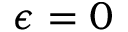<formula> <loc_0><loc_0><loc_500><loc_500>\epsilon = 0</formula> 